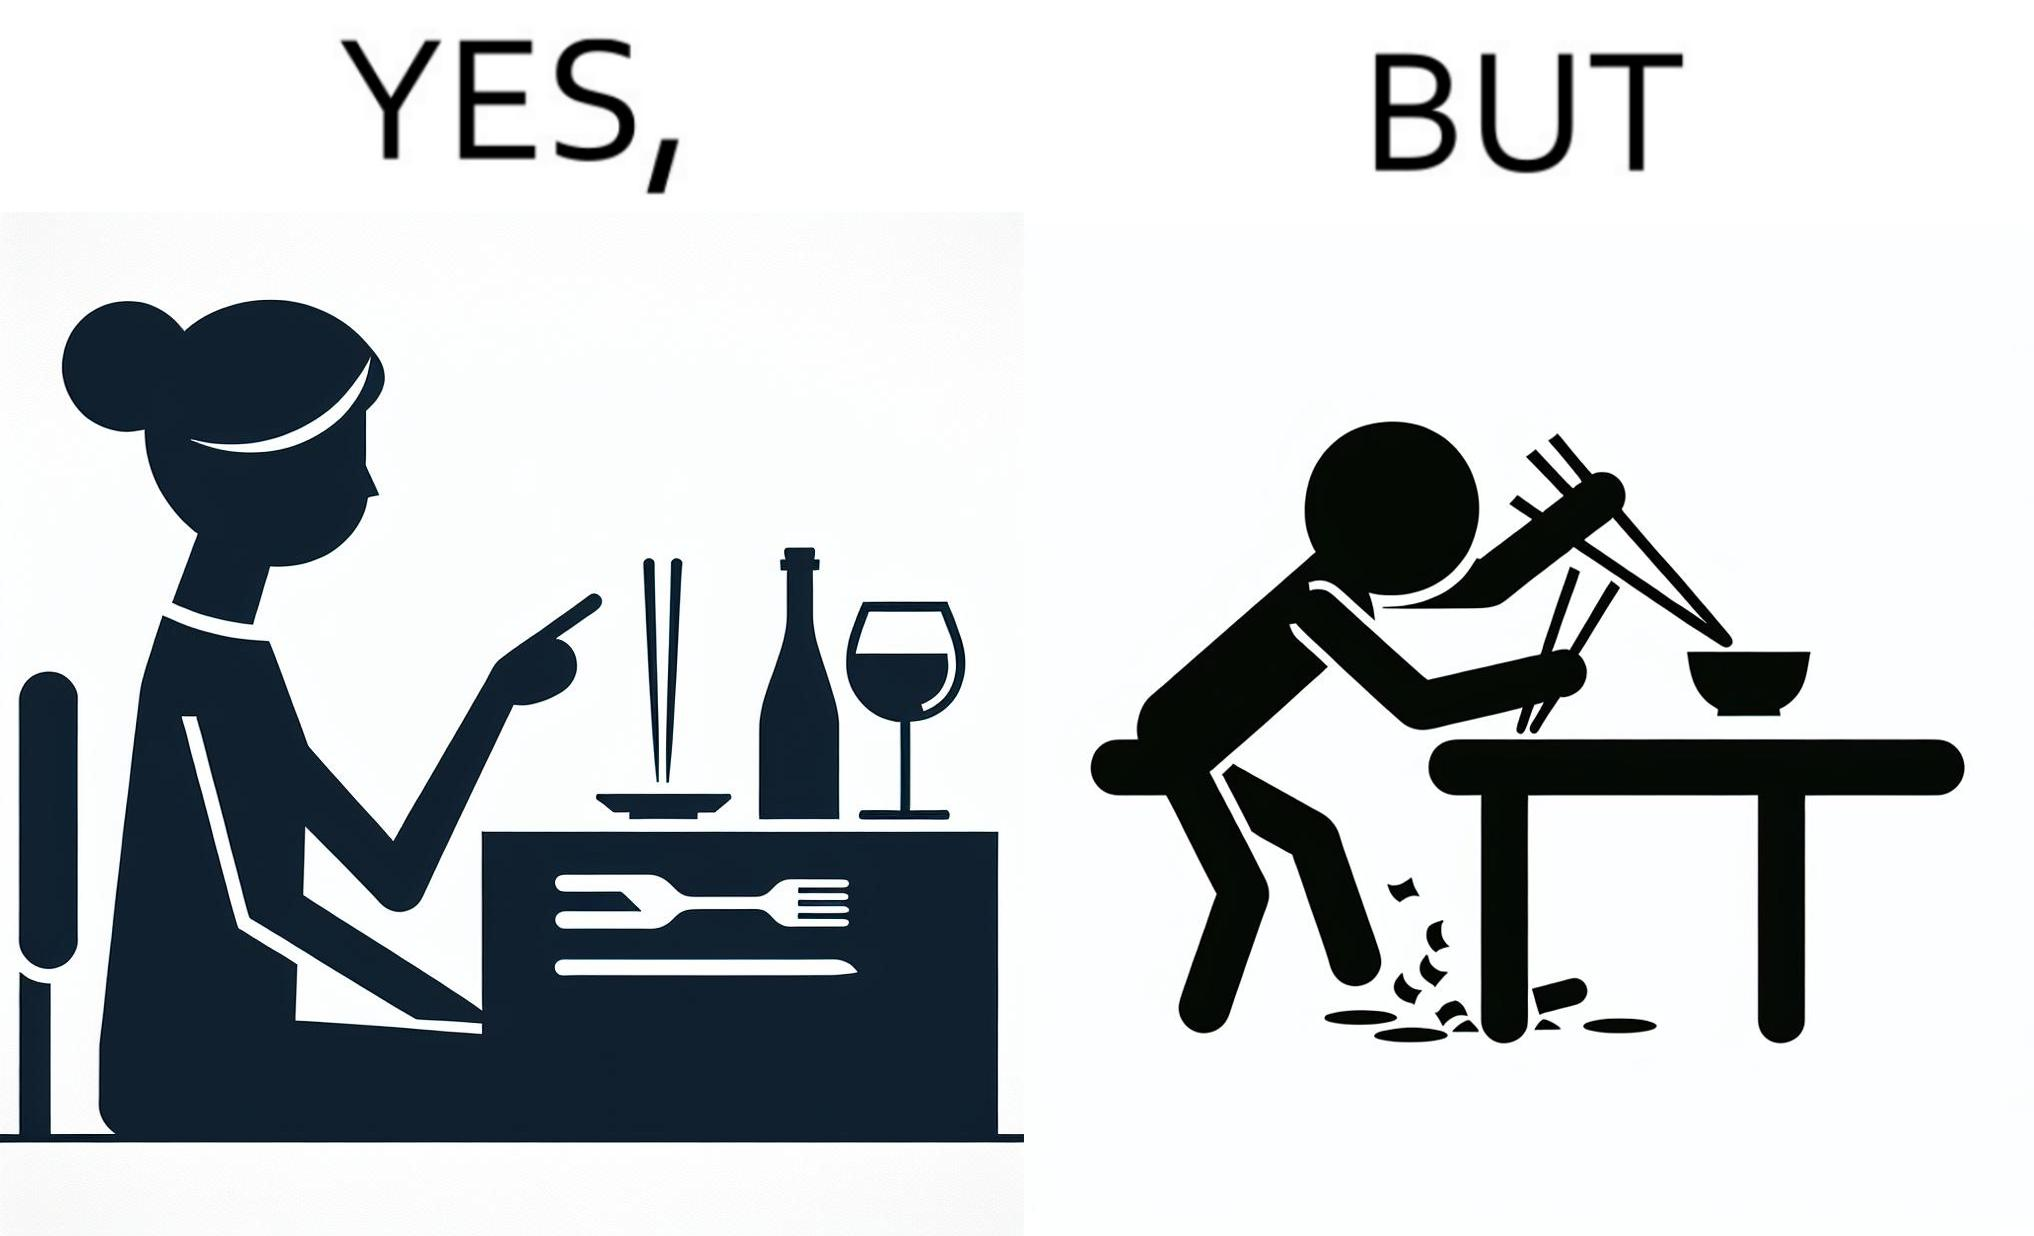What makes this image funny or satirical? The image is satirical because even thought the woman is not able to eat food with chopstick properly, she chooses it over fork and knife to look sophisticaed. 